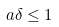<formula> <loc_0><loc_0><loc_500><loc_500>a \delta \leq 1</formula> 